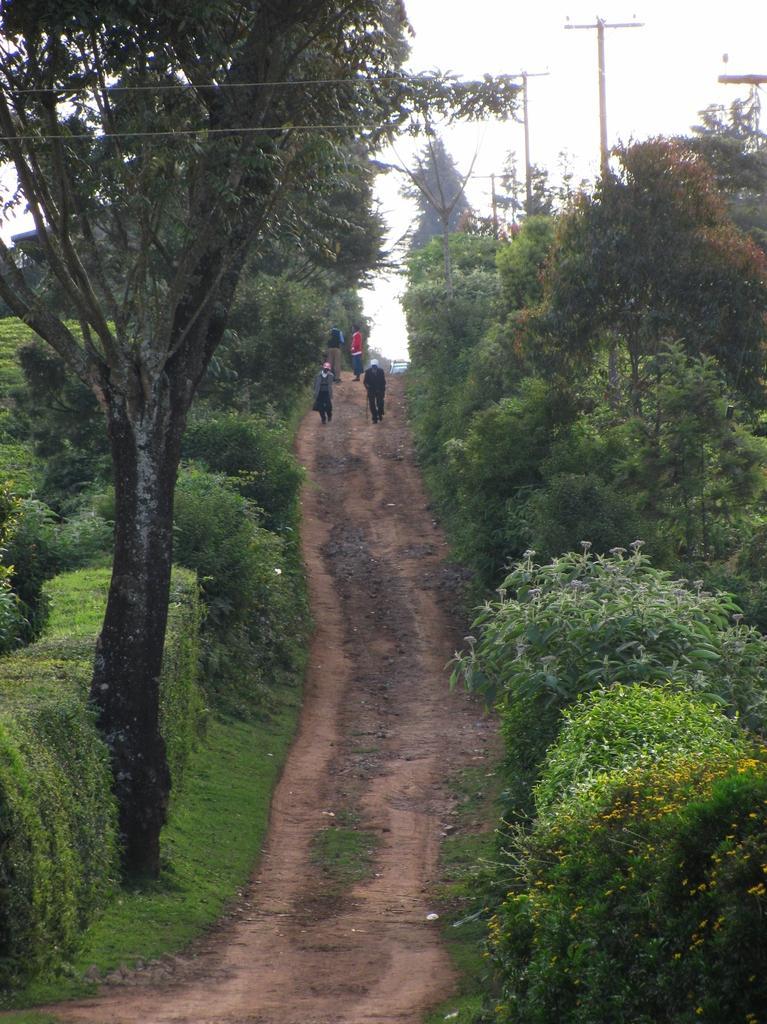Describe this image in one or two sentences. In this picture we can see a few people on the path. There are some plants on the right and left side of the path. We can see a few trees and poles in the background. 